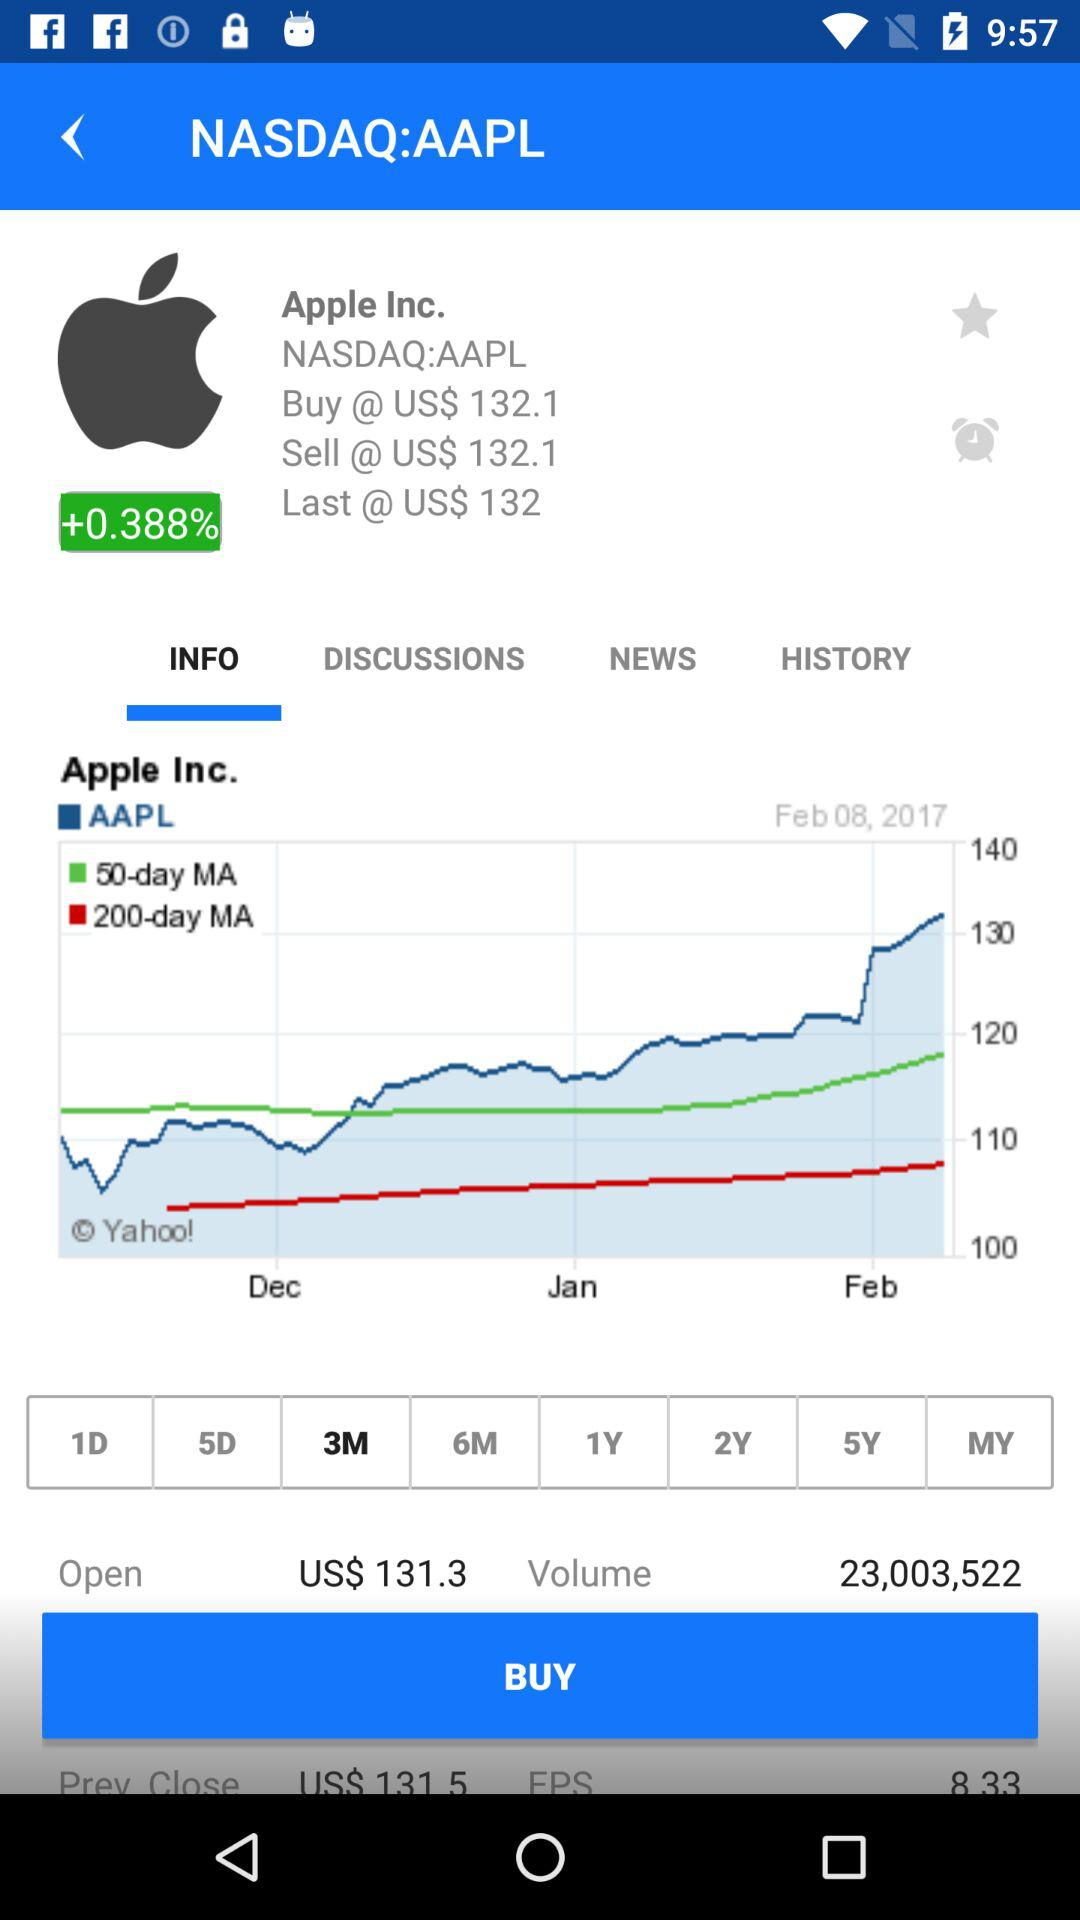Which option is selected in the bar? The selected option is "3M". 